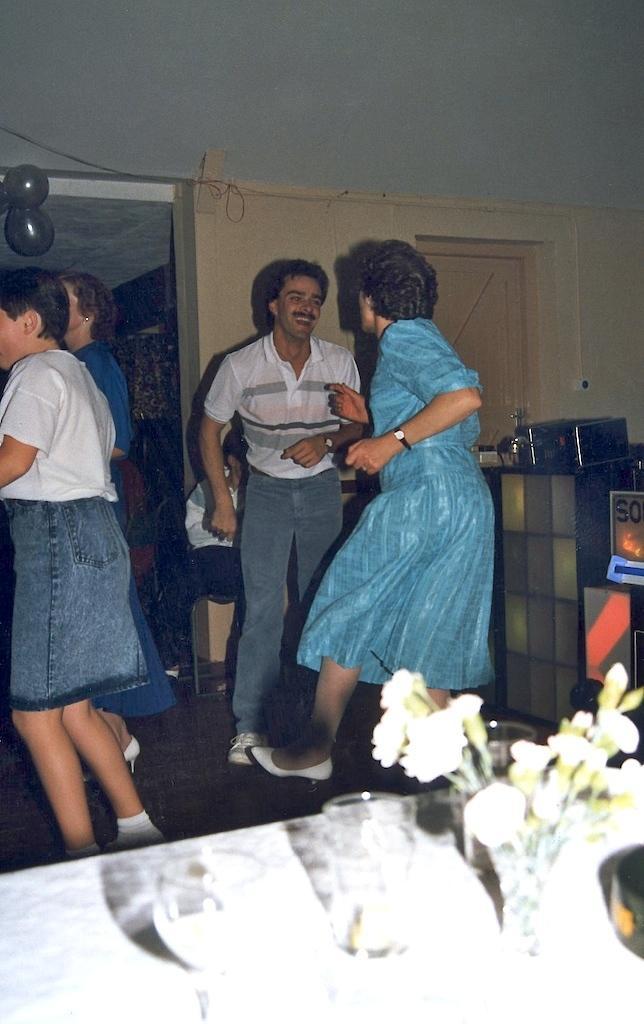Could you give a brief overview of what you see in this image? In this picture I can see four persons standing, there are glasses, flower vase and some other items on the table, there are balloons, and in the background there is a door and a wall. 